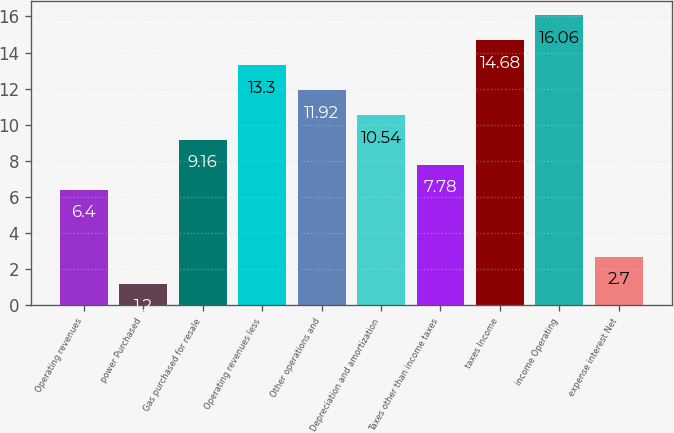<chart> <loc_0><loc_0><loc_500><loc_500><bar_chart><fcel>Operating revenues<fcel>power Purchased<fcel>Gas purchased for resale<fcel>Operating revenues less<fcel>Other operations and<fcel>Depreciation and amortization<fcel>Taxes other than income taxes<fcel>taxes Income<fcel>income Operating<fcel>expense interest Net<nl><fcel>6.4<fcel>1.2<fcel>9.16<fcel>13.3<fcel>11.92<fcel>10.54<fcel>7.78<fcel>14.68<fcel>16.06<fcel>2.7<nl></chart> 